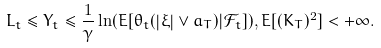<formula> <loc_0><loc_0><loc_500><loc_500>L _ { t } \leq Y _ { t } \leq \frac { 1 } { \gamma } \ln ( E [ \theta _ { t } ( \left | \xi \right | \vee a _ { T } ) | \mathcal { F } _ { t } ] ) , E [ ( K _ { T } ) ^ { 2 } ] < + \infty .</formula> 